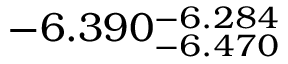<formula> <loc_0><loc_0><loc_500><loc_500>- 6 . 3 9 0 _ { - 6 . 4 7 0 } ^ { - 6 . 2 8 4 }</formula> 